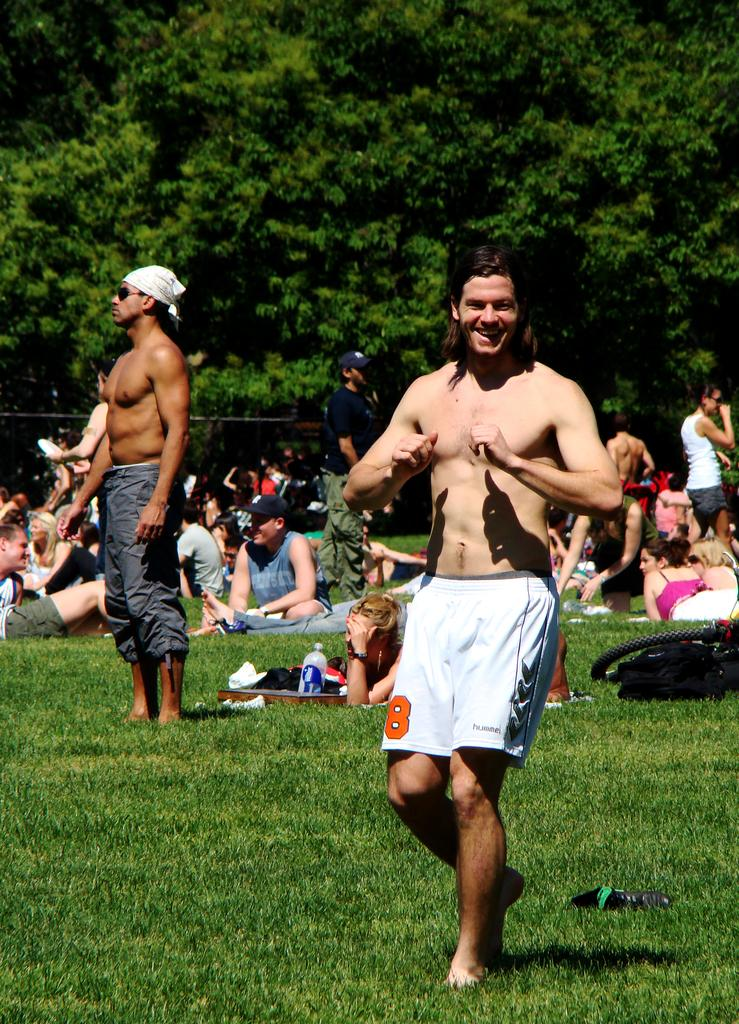<image>
Offer a succinct explanation of the picture presented. a man with no shirt on grass with the number 8 on his shorts 